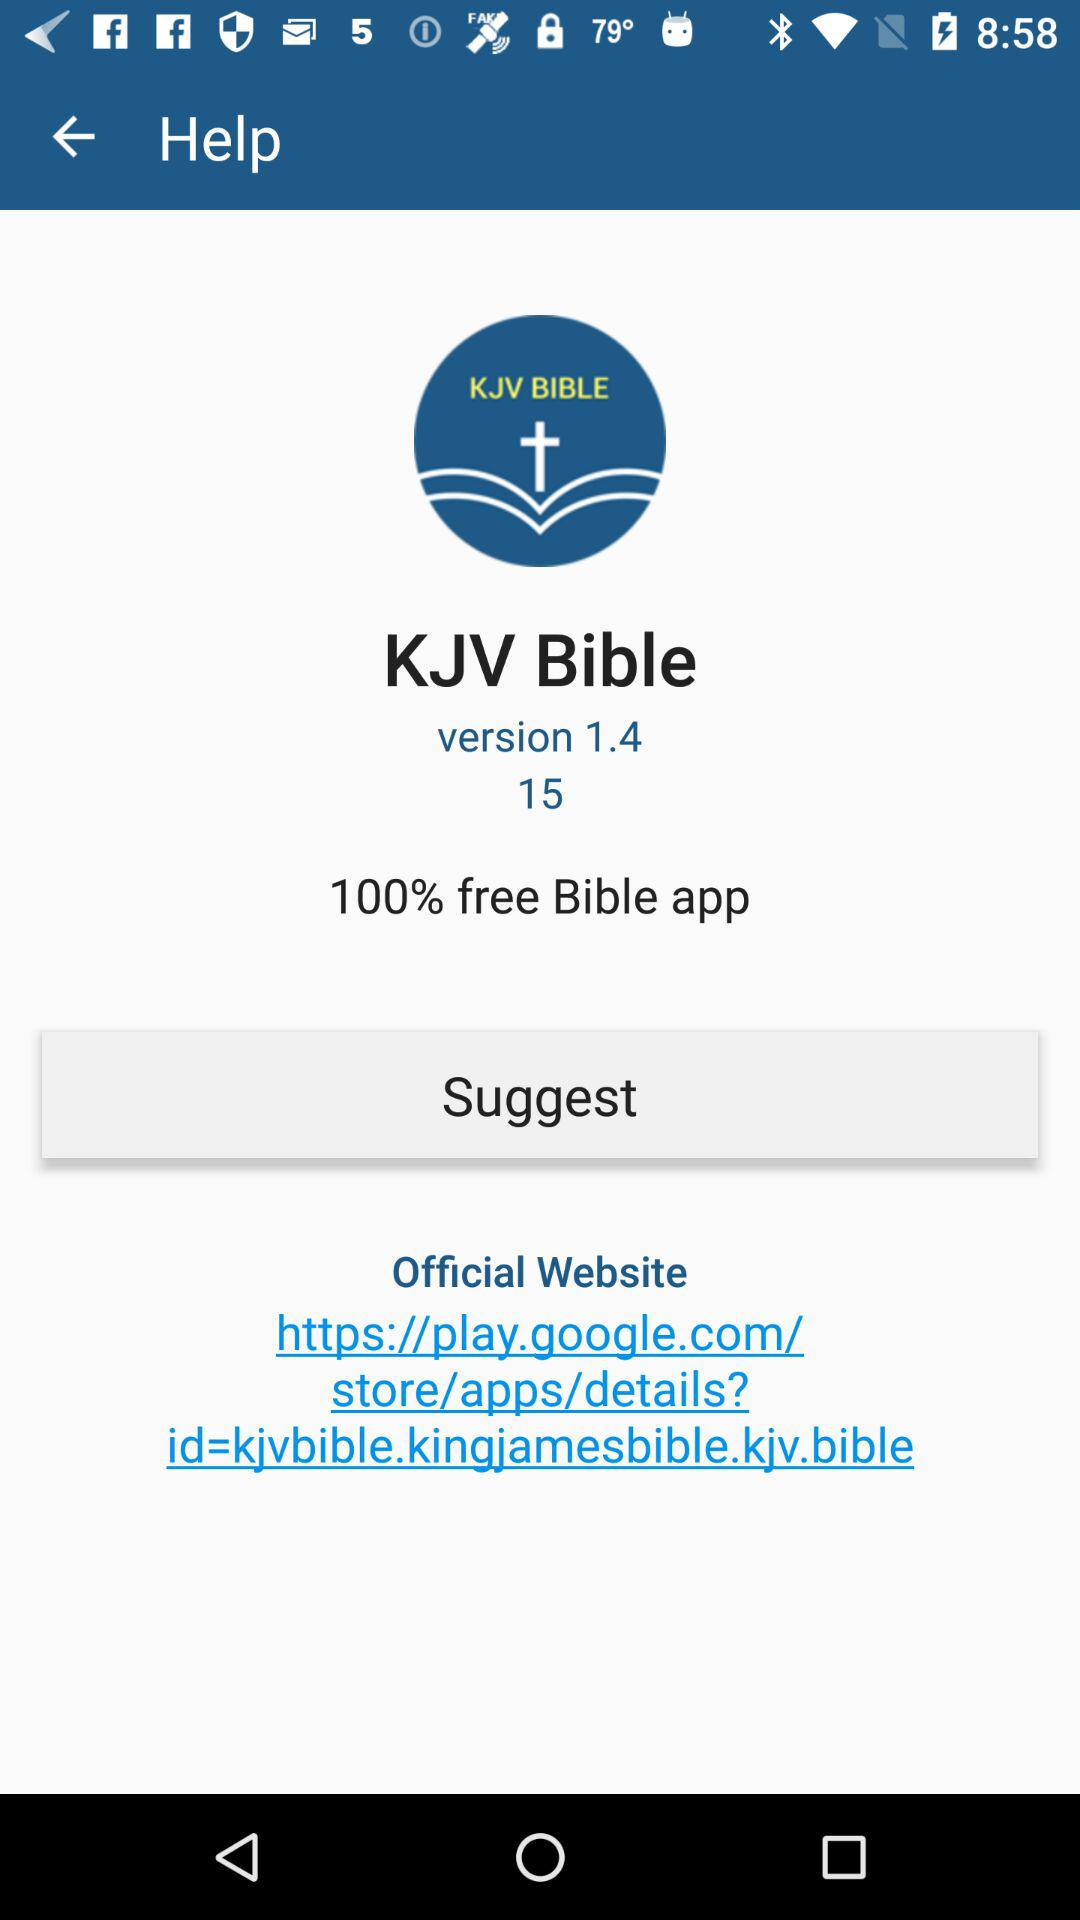What percentage of the "Bible" app is free? The "Bible" app is 100% free. 